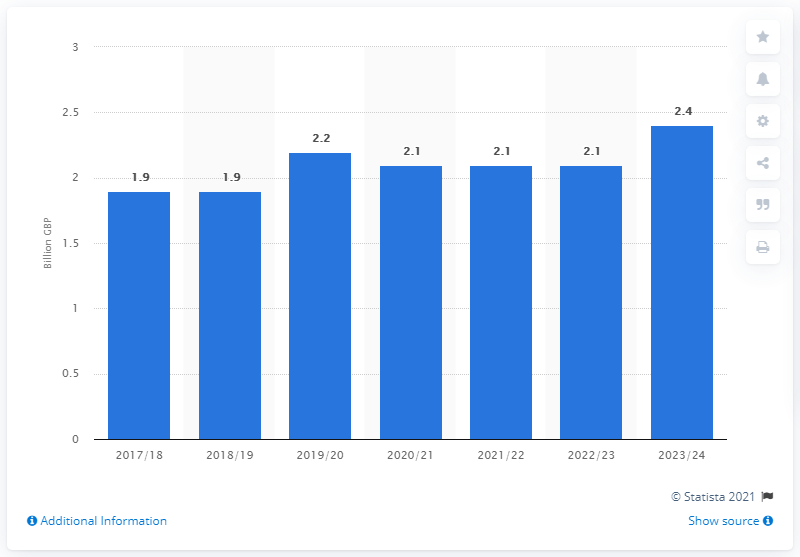Indicate a few pertinent items in this graphic. The estimated amount of levies that the UK is expected to receive in 2023/24 is 2.4. It is expected that the UK will begin receiving climate change levies in the fiscal year 2017/18. The UK expects to receive climate change levies in the fiscal year 2023/24. 